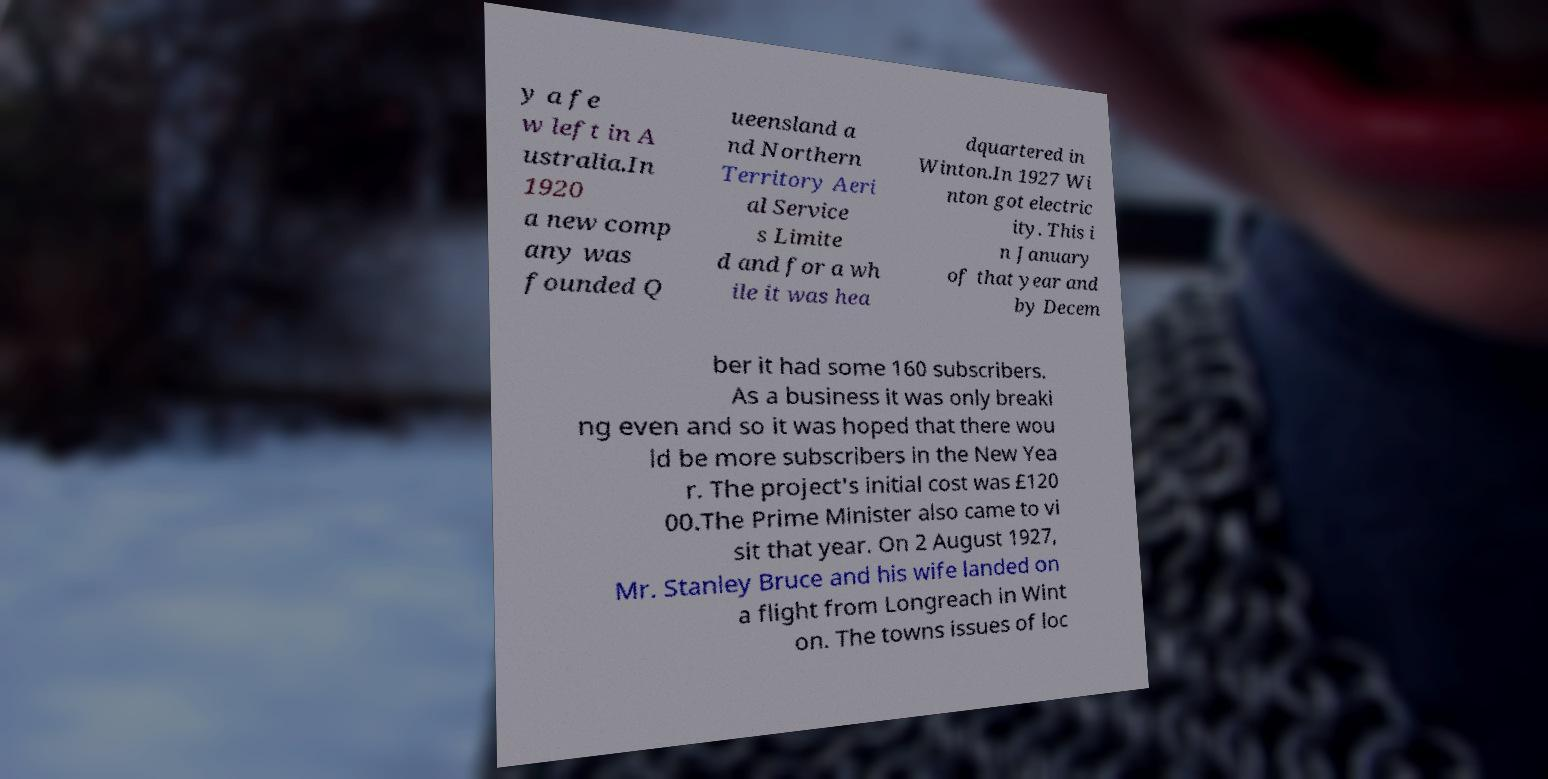Can you accurately transcribe the text from the provided image for me? y a fe w left in A ustralia.In 1920 a new comp any was founded Q ueensland a nd Northern Territory Aeri al Service s Limite d and for a wh ile it was hea dquartered in Winton.In 1927 Wi nton got electric ity. This i n January of that year and by Decem ber it had some 160 subscribers. As a business it was only breaki ng even and so it was hoped that there wou ld be more subscribers in the New Yea r. The project's initial cost was £120 00.The Prime Minister also came to vi sit that year. On 2 August 1927, Mr. Stanley Bruce and his wife landed on a flight from Longreach in Wint on. The towns issues of loc 